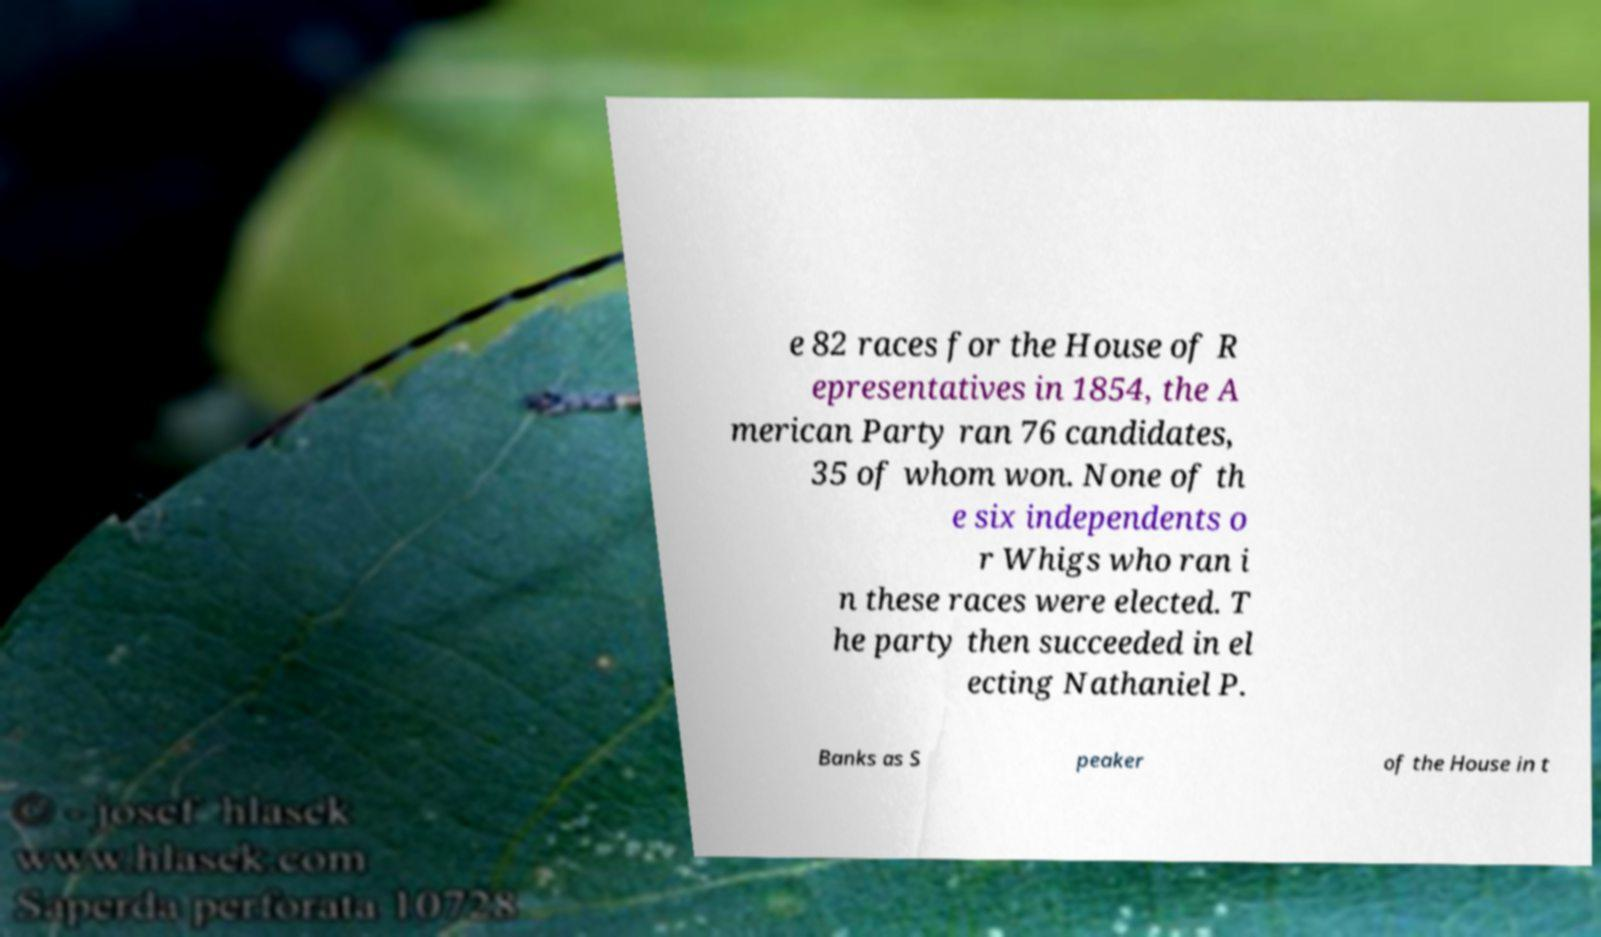Can you accurately transcribe the text from the provided image for me? e 82 races for the House of R epresentatives in 1854, the A merican Party ran 76 candidates, 35 of whom won. None of th e six independents o r Whigs who ran i n these races were elected. T he party then succeeded in el ecting Nathaniel P. Banks as S peaker of the House in t 